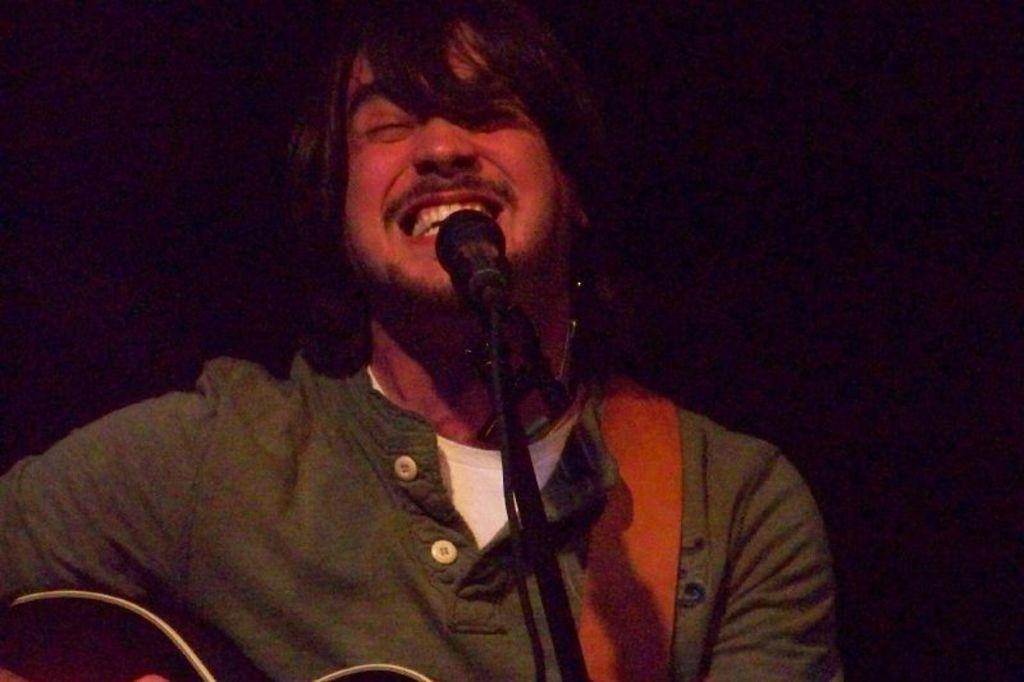Who is the main subject in the image? There is a man in the image. What is the man holding in the image? The man is holding a guitar. What other object is present in the image related to performing? There is a microphone in the image. How is the microphone positioned in the image? The microphone is on a stand. What can be inferred about the lighting conditions in the image? The background of the image is dark. What type of nut is being cracked by the man in the image? There is no nut present in the image; the man is holding a guitar. How many wings does the man have in the image? The man does not have any wings in the image; he is a human holding a guitar. 